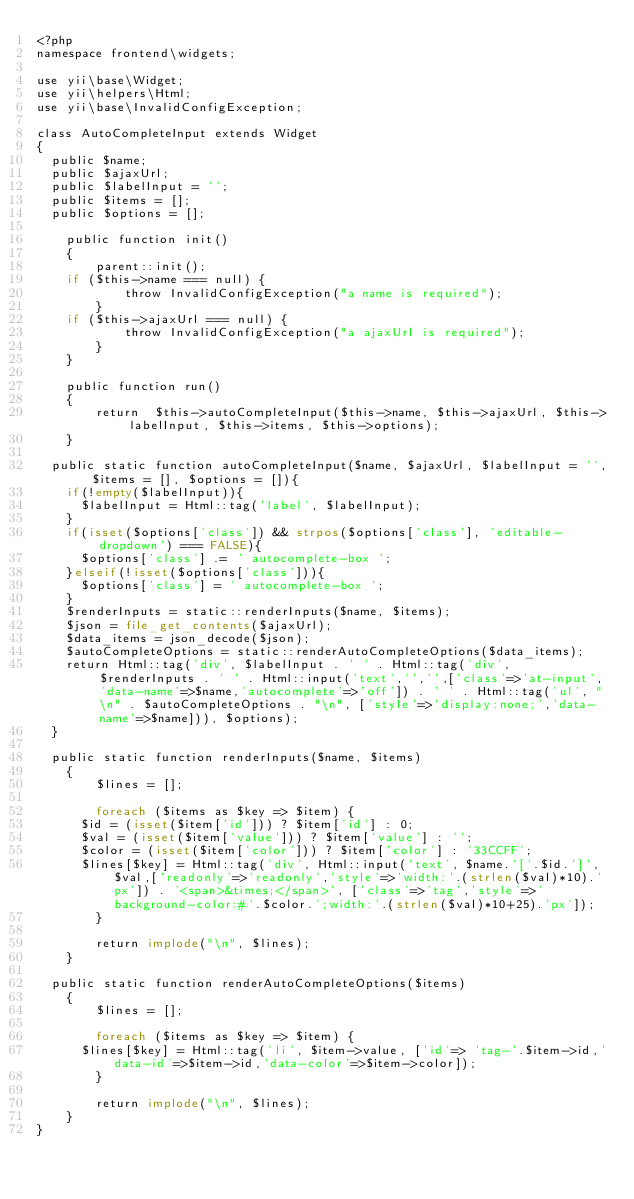<code> <loc_0><loc_0><loc_500><loc_500><_PHP_><?php
namespace frontend\widgets;

use yii\base\Widget;
use yii\helpers\Html;
use yii\base\InvalidConfigException;

class AutoCompleteInput extends Widget
{
	public $name;
	public $ajaxUrl;
	public $labelInput = '';
	public $items = [];
	public $options = [];

    public function init()
    {
        parent::init();
		if ($this->name === null) {
            throw InvalidConfigException("a name is required");
        }
		if ($this->ajaxUrl === null) {
            throw InvalidConfigException("a ajaxUrl is required");
        }
    }

    public function run()
    {
        return 	$this->autoCompleteInput($this->name, $this->ajaxUrl, $this->labelInput, $this->items, $this->options);
    }
	
	public static function autoCompleteInput($name, $ajaxUrl, $labelInput = '', $items = [], $options = []){
		if(!empty($labelInput)){
			$labelInput = Html::tag('label', $labelInput);
		}
		if(isset($options['class']) && strpos($options['class'], 'editable-dropdown') === FALSE){
			$options['class'] .= ' autocomplete-box ';
		}elseif(!isset($options['class'])){
			$options['class'] = ' autocomplete-box ';
		}
		$renderInputs = static::renderInputs($name, $items);
		$json = file_get_contents($ajaxUrl);
		$data_items = json_decode($json);
		$autoCompleteOptions = static::renderAutoCompleteOptions($data_items);
		return Html::tag('div', $labelInput . ' ' . Html::tag('div', $renderInputs . ' ' . Html::input('text','','',['class'=>'at-input','data-name'=>$name,'autocomplete'=>'off']) . ' ' . Html::tag('ul', "\n" . $autoCompleteOptions . "\n", ['style'=>'display:none;','data-name'=>$name])), $options);
	}
	
	public static function renderInputs($name, $items)
    {
        $lines = [];

        foreach ($items as $key => $item) {
			$id = (isset($item['id'])) ? $item['id'] : 0;
			$val = (isset($item['value'])) ? $item['value'] : '';
			$color = (isset($item['color'])) ? $item['color'] : '33CCFF';
			$lines[$key] = Html::tag('div', Html::input('text', $name.'['.$id.']', $val,['readonly'=>'readonly','style'=>'width:'.(strlen($val)*10).'px']) . '<span>&times;</span>', ['class'=>'tag','style'=>'background-color:#'.$color.';width:'.(strlen($val)*10+25).'px']);
        }

        return implode("\n", $lines);
    }
	
	public static function renderAutoCompleteOptions($items)
    {
        $lines = [];

        foreach ($items as $key => $item) {
			$lines[$key] = Html::tag('li', $item->value, ['id'=> 'tag-'.$item->id,'data-id'=>$item->id,'data-color'=>$item->color]);
        }

        return implode("\n", $lines);
    }
}
</code> 